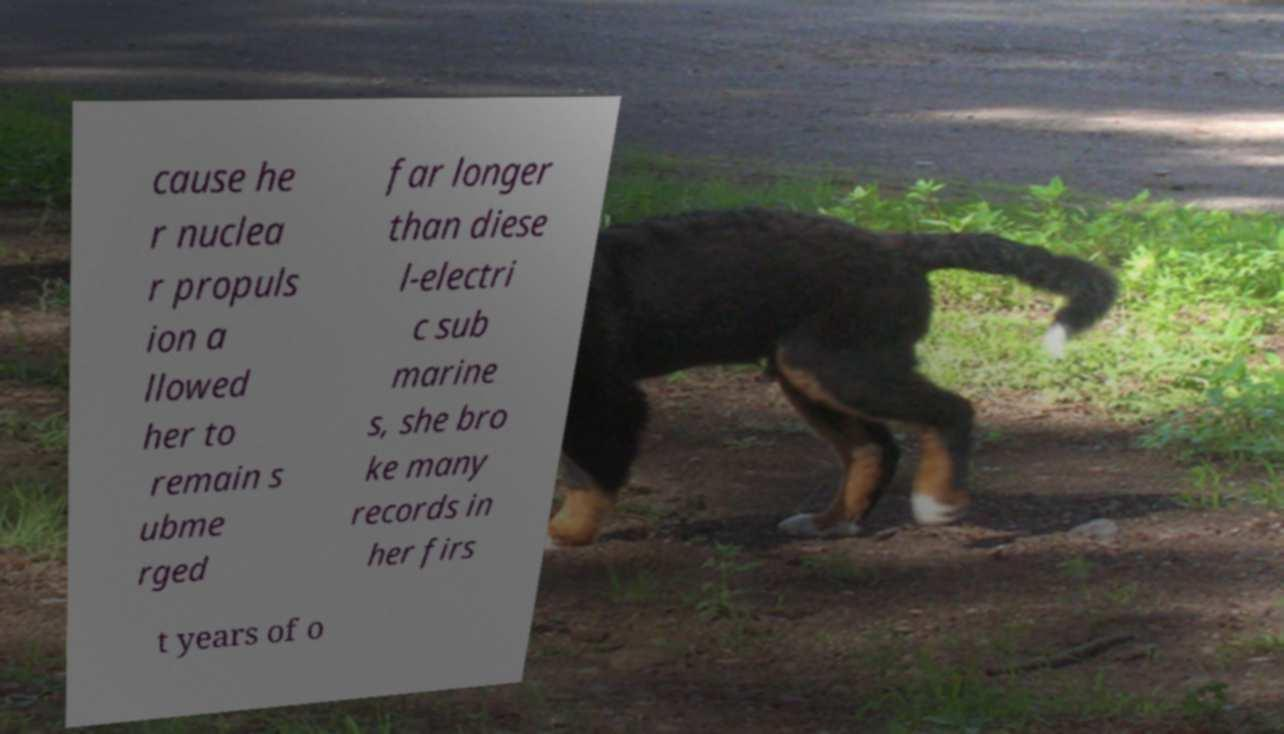Please read and relay the text visible in this image. What does it say? cause he r nuclea r propuls ion a llowed her to remain s ubme rged far longer than diese l-electri c sub marine s, she bro ke many records in her firs t years of o 